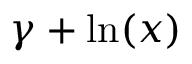<formula> <loc_0><loc_0><loc_500><loc_500>\gamma + \ln ( x )</formula> 